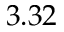Convert formula to latex. <formula><loc_0><loc_0><loc_500><loc_500>3 . 3 2</formula> 